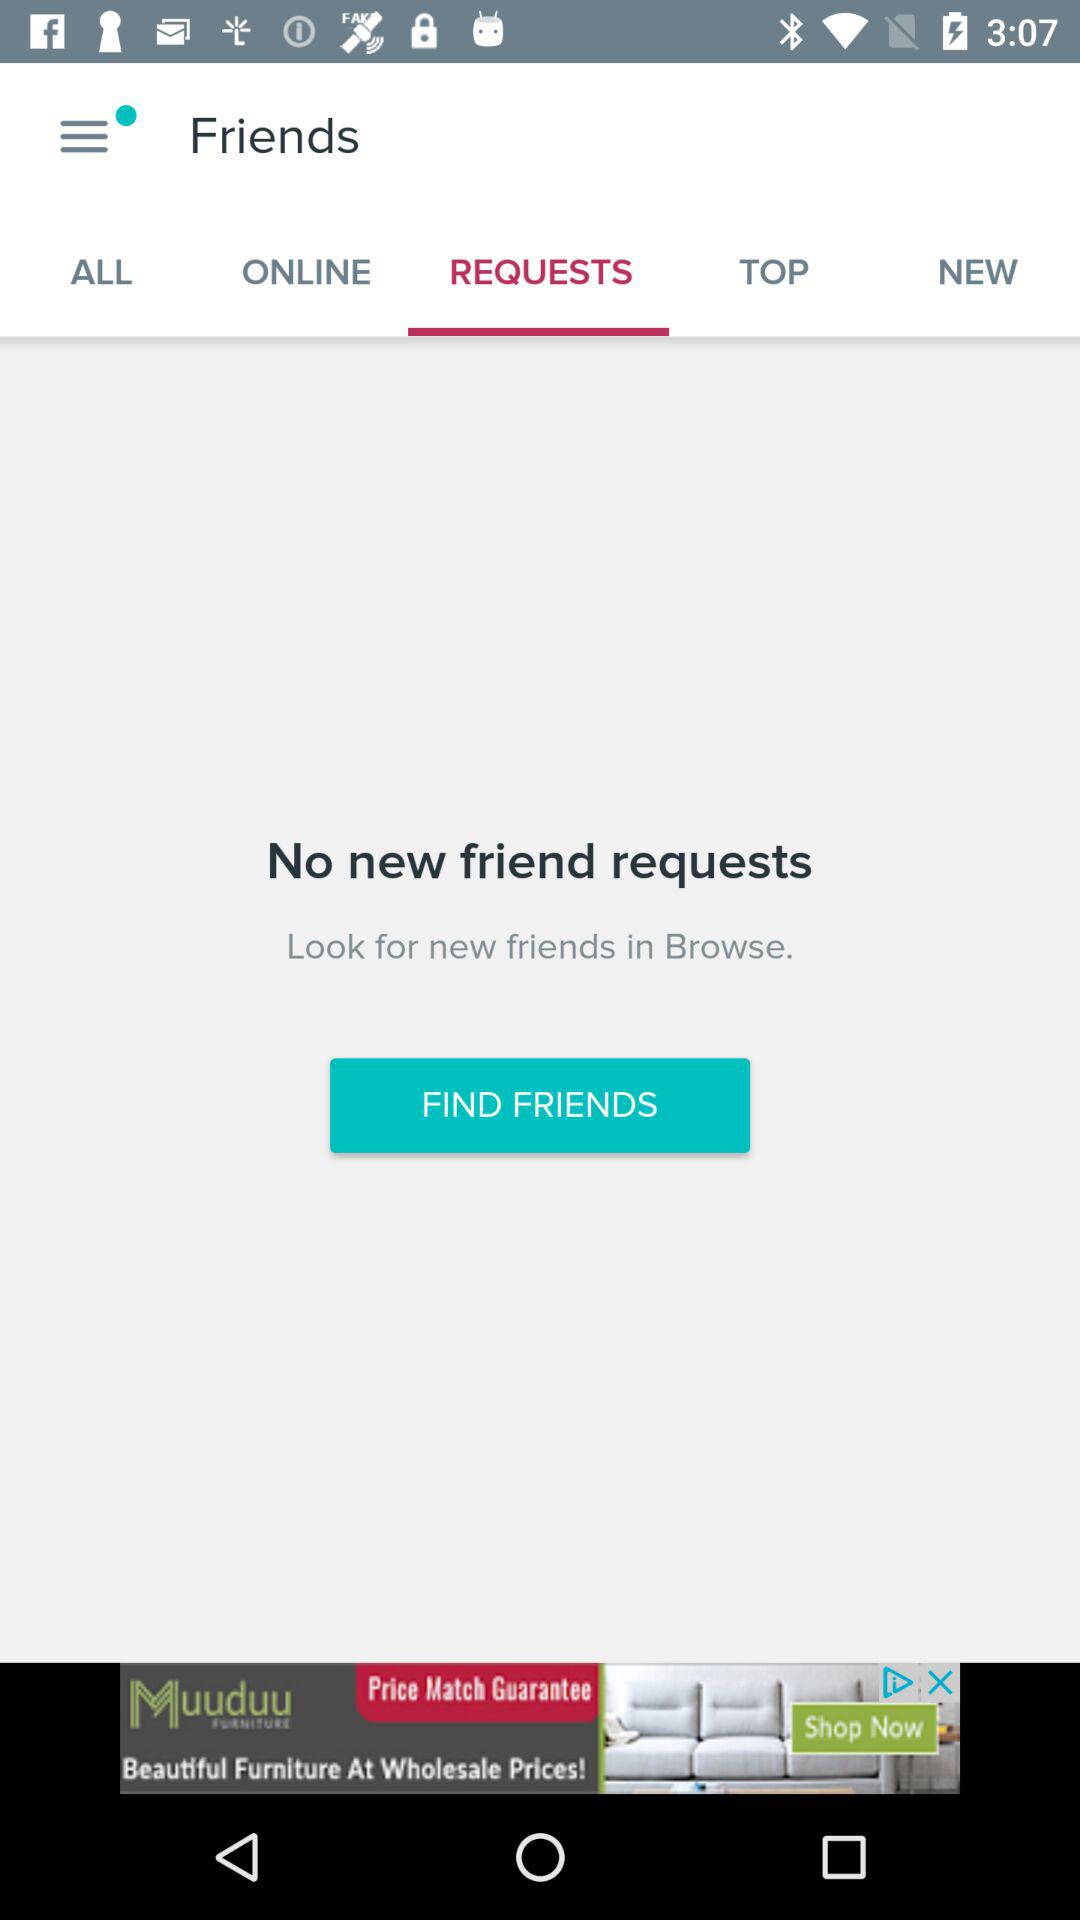How many requests are there? There are no requests. 